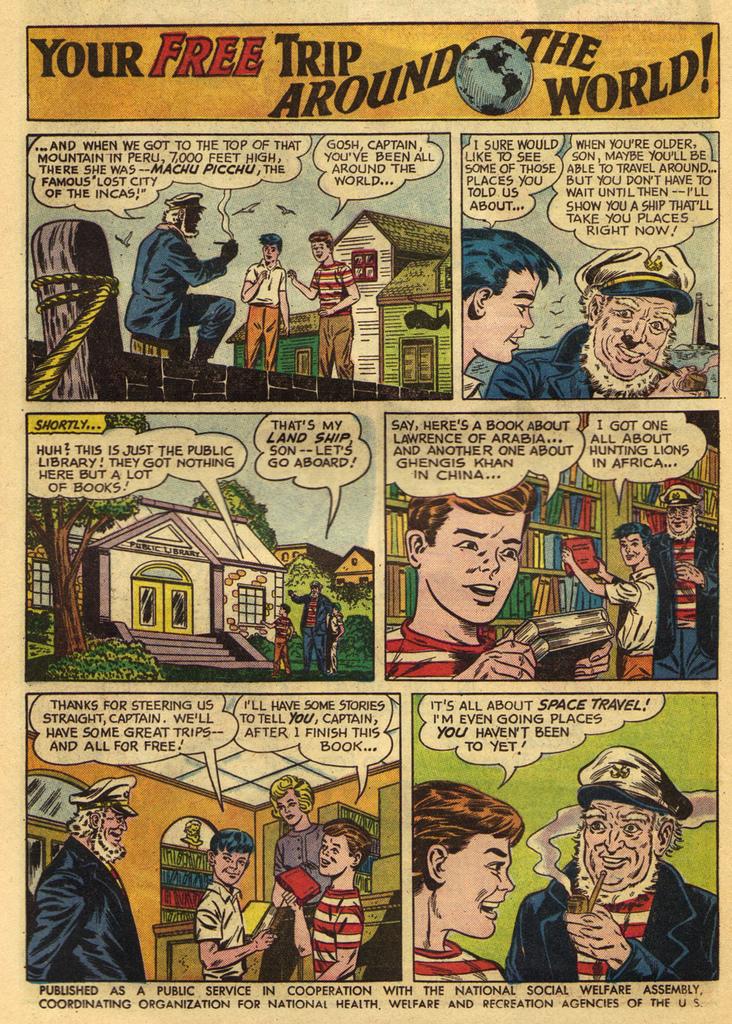Who was the publisher of this comic?
Give a very brief answer. National social welfare assembly. What is the story line of this comic?
Offer a terse response. Your free trip around the world. 